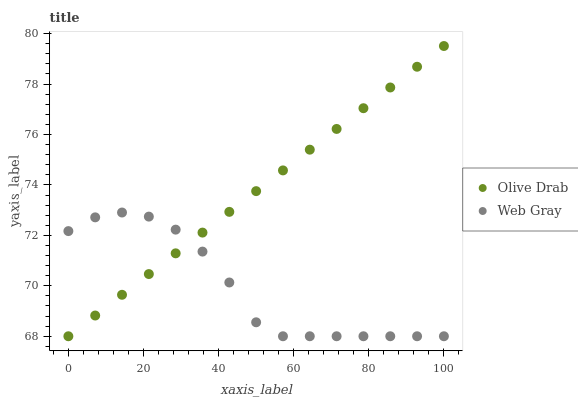Does Web Gray have the minimum area under the curve?
Answer yes or no. Yes. Does Olive Drab have the maximum area under the curve?
Answer yes or no. Yes. Does Olive Drab have the minimum area under the curve?
Answer yes or no. No. Is Olive Drab the smoothest?
Answer yes or no. Yes. Is Web Gray the roughest?
Answer yes or no. Yes. Is Olive Drab the roughest?
Answer yes or no. No. Does Web Gray have the lowest value?
Answer yes or no. Yes. Does Olive Drab have the highest value?
Answer yes or no. Yes. Does Olive Drab intersect Web Gray?
Answer yes or no. Yes. Is Olive Drab less than Web Gray?
Answer yes or no. No. Is Olive Drab greater than Web Gray?
Answer yes or no. No. 